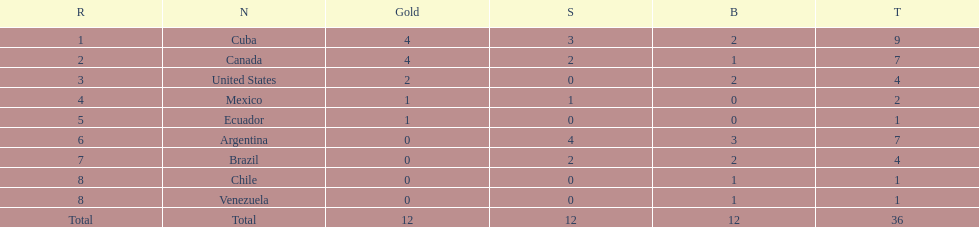How many total medals did argentina win? 7. 